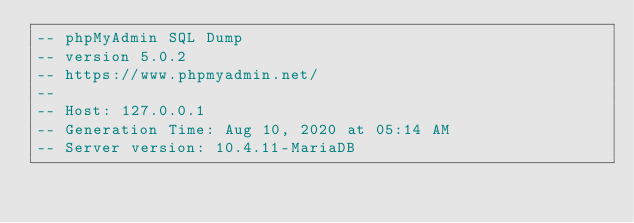<code> <loc_0><loc_0><loc_500><loc_500><_SQL_>-- phpMyAdmin SQL Dump
-- version 5.0.2
-- https://www.phpmyadmin.net/
--
-- Host: 127.0.0.1
-- Generation Time: Aug 10, 2020 at 05:14 AM
-- Server version: 10.4.11-MariaDB</code> 